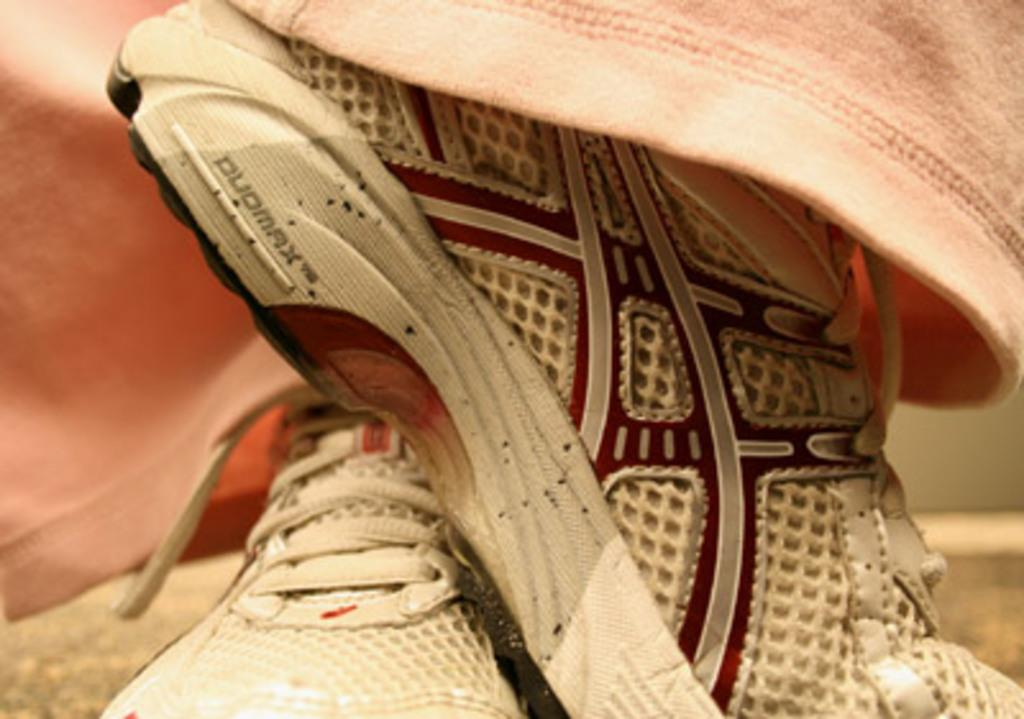What type of footwear is visible in the image? There is a pair of shoes in the image. What else can be seen in the image besides the shoes? There are clothes in the image. What type of plantation is visible in the image? There is no plantation present in the image; it only features a pair of shoes and clothes. What class of people might be associated with the clothes in the image? The image does not provide enough information to determine the class of people associated with the clothes. 